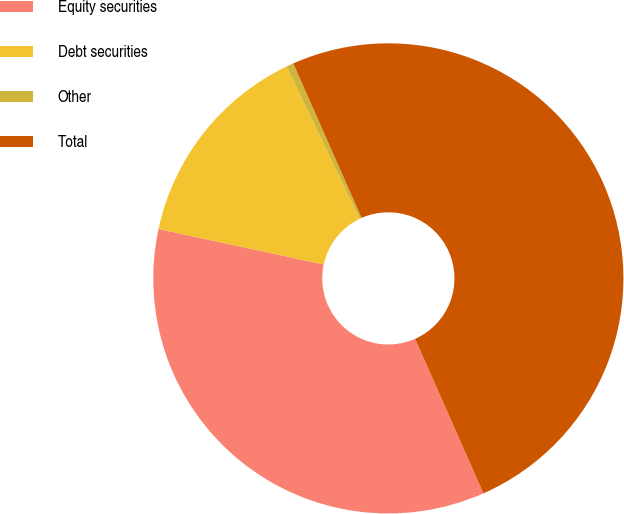Convert chart to OTSL. <chart><loc_0><loc_0><loc_500><loc_500><pie_chart><fcel>Equity securities<fcel>Debt securities<fcel>Other<fcel>Total<nl><fcel>35.0%<fcel>14.5%<fcel>0.5%<fcel>50.0%<nl></chart> 